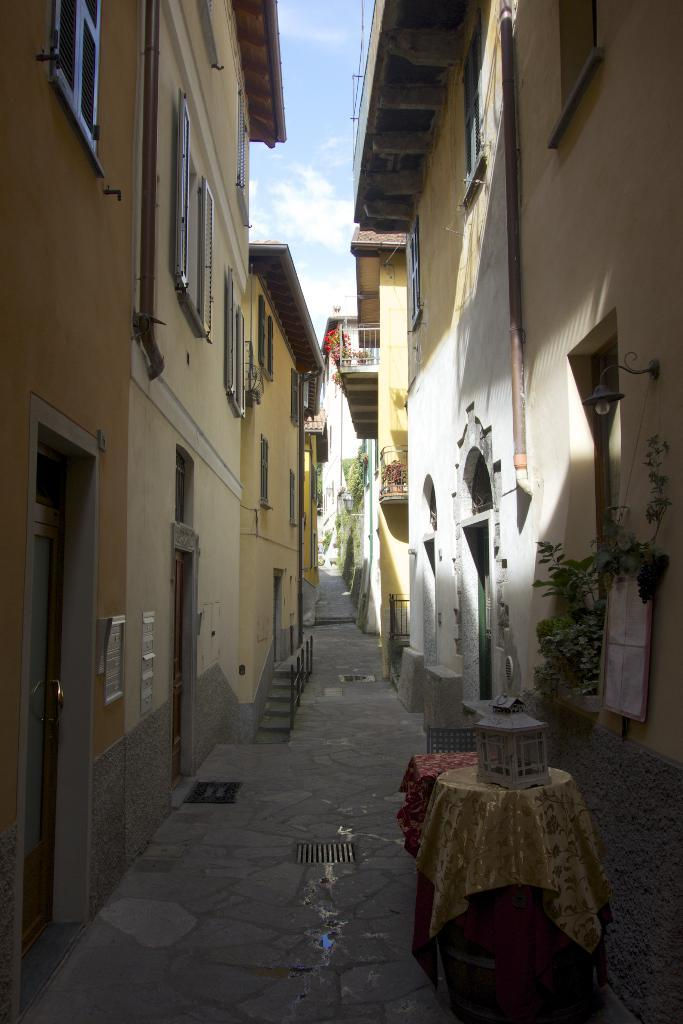What can be seen in the foreground of the image? There is a path in the image. What else is present in the image besides the path? There is an unspecified object in the image. What can be seen in the background of the image? There are buildings, plants, and the sky visible in the background of the image. Can you describe the fang of the creature in the image? There is no creature with a fang present in the image. What type of banana can be seen on the throne in the image? There is no banana or throne present in the image. 